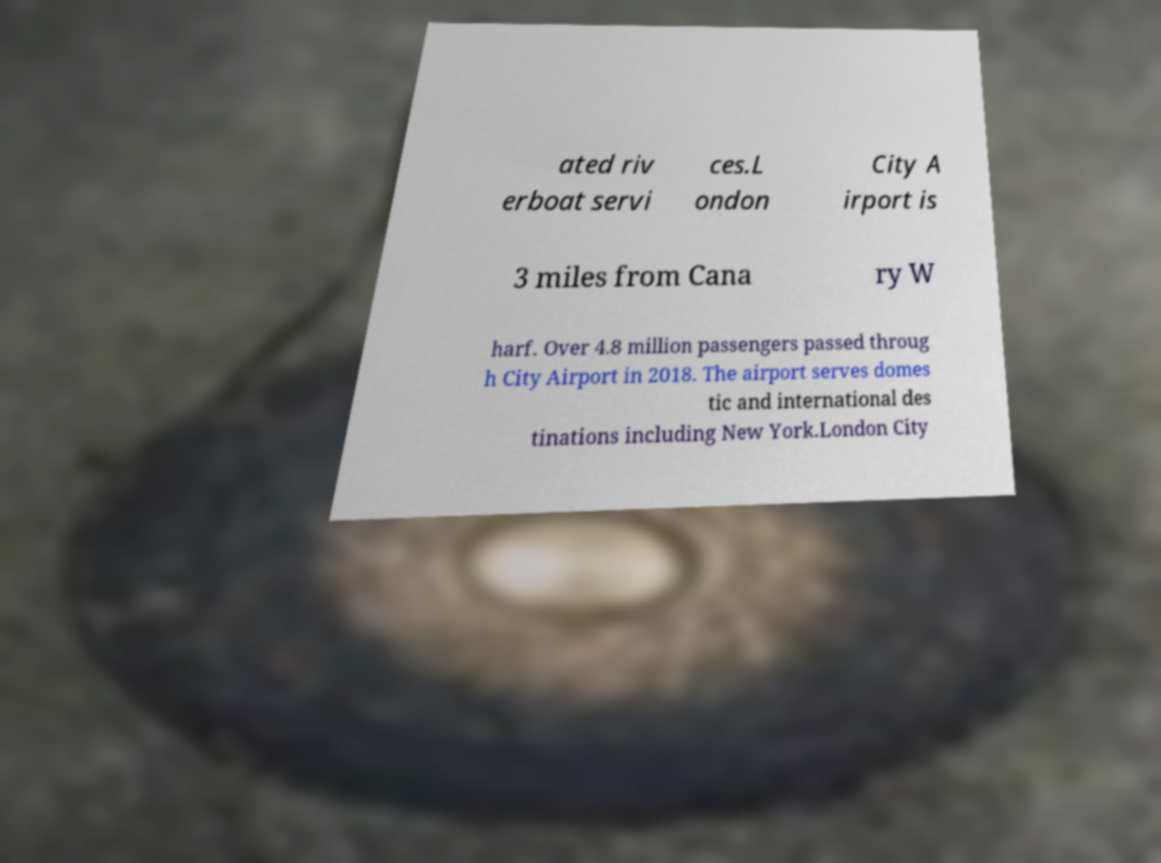Could you extract and type out the text from this image? ated riv erboat servi ces.L ondon City A irport is 3 miles from Cana ry W harf. Over 4.8 million passengers passed throug h City Airport in 2018. The airport serves domes tic and international des tinations including New York.London City 